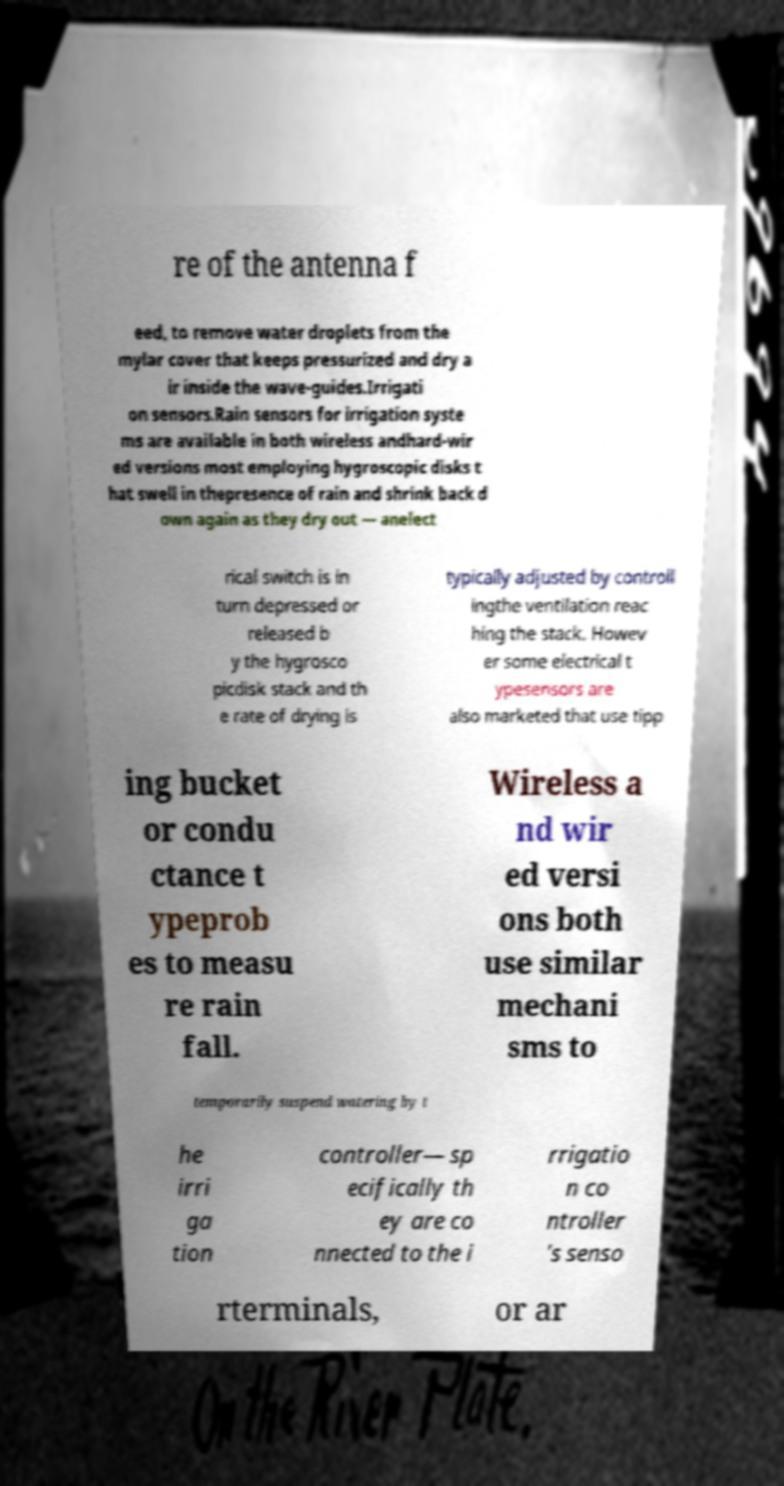For documentation purposes, I need the text within this image transcribed. Could you provide that? re of the antenna f eed, to remove water droplets from the mylar cover that keeps pressurized and dry a ir inside the wave-guides.Irrigati on sensors.Rain sensors for irrigation syste ms are available in both wireless andhard-wir ed versions most employing hygroscopic disks t hat swell in thepresence of rain and shrink back d own again as they dry out — anelect rical switch is in turn depressed or released b y the hygrosco picdisk stack and th e rate of drying is typically adjusted by controll ingthe ventilation reac hing the stack. Howev er some electrical t ypesensors are also marketed that use tipp ing bucket or condu ctance t ypeprob es to measu re rain fall. Wireless a nd wir ed versi ons both use similar mechani sms to temporarily suspend watering by t he irri ga tion controller— sp ecifically th ey are co nnected to the i rrigatio n co ntroller 's senso rterminals, or ar 